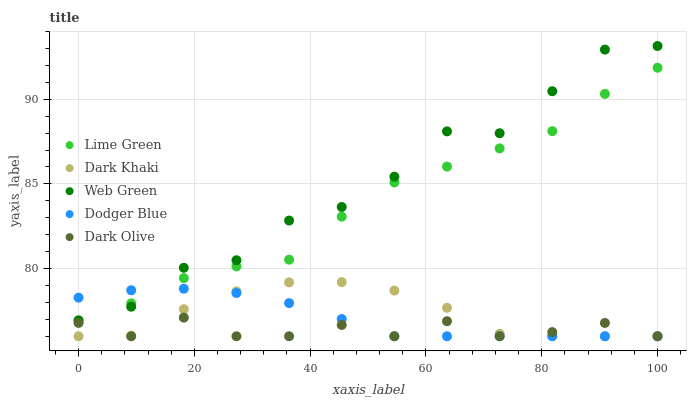Does Dark Olive have the minimum area under the curve?
Answer yes or no. Yes. Does Web Green have the maximum area under the curve?
Answer yes or no. Yes. Does Dodger Blue have the minimum area under the curve?
Answer yes or no. No. Does Dodger Blue have the maximum area under the curve?
Answer yes or no. No. Is Dodger Blue the smoothest?
Answer yes or no. Yes. Is Web Green the roughest?
Answer yes or no. Yes. Is Dark Olive the smoothest?
Answer yes or no. No. Is Dark Olive the roughest?
Answer yes or no. No. Does Dark Khaki have the lowest value?
Answer yes or no. Yes. Does Lime Green have the lowest value?
Answer yes or no. No. Does Web Green have the highest value?
Answer yes or no. Yes. Does Dodger Blue have the highest value?
Answer yes or no. No. Is Dark Khaki less than Web Green?
Answer yes or no. Yes. Is Web Green greater than Dark Khaki?
Answer yes or no. Yes. Does Web Green intersect Lime Green?
Answer yes or no. Yes. Is Web Green less than Lime Green?
Answer yes or no. No. Is Web Green greater than Lime Green?
Answer yes or no. No. Does Dark Khaki intersect Web Green?
Answer yes or no. No. 